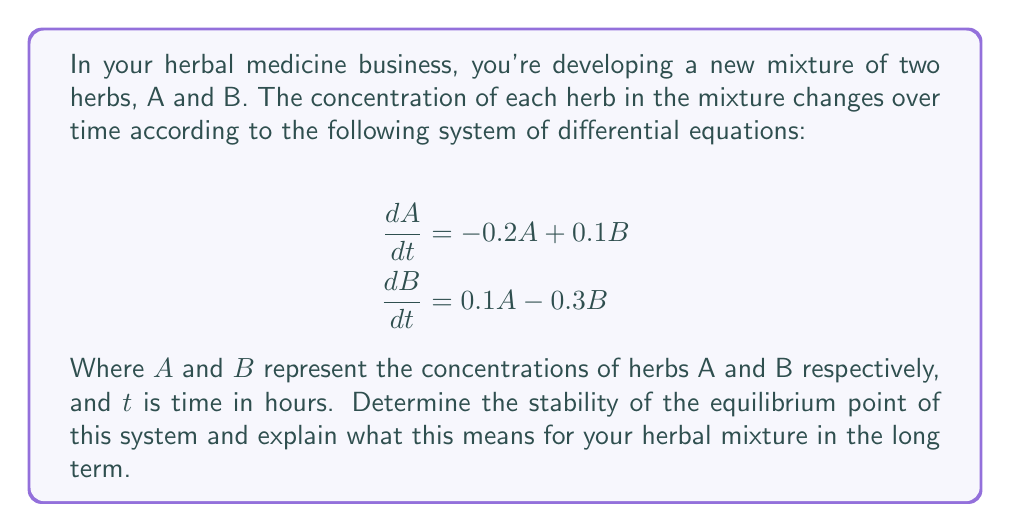Solve this math problem. 1) First, we need to find the equilibrium point by setting both equations to zero:

   $$-0.2A + 0.1B = 0$$
   $$0.1A - 0.3B = 0$$

2) Solving these equations simultaneously:
   From the second equation: $A = 3B$
   Substituting into the first equation:
   $$-0.2(3B) + 0.1B = 0$$
   $$-0.6B + 0.1B = 0$$
   $$-0.5B = 0$$
   $$B = 0$$

   Therefore, $A = 0$ as well.

3) The equilibrium point is (0,0).

4) To determine stability, we need to find the Jacobian matrix:

   $$J = \begin{bmatrix}
   \frac{\partial}{\partial A}(-0.2A + 0.1B) & \frac{\partial}{\partial B}(-0.2A + 0.1B) \\
   \frac{\partial}{\partial A}(0.1A - 0.3B) & \frac{\partial}{\partial B}(0.1A - 0.3B)
   \end{bmatrix}$$

   $$J = \begin{bmatrix}
   -0.2 & 0.1 \\
   0.1 & -0.3
   \end{bmatrix}$$

5) Calculate the eigenvalues of J:
   $$det(J - \lambda I) = 0$$
   $$\begin{vmatrix}
   -0.2 - \lambda & 0.1 \\
   0.1 & -0.3 - \lambda
   \end{vmatrix} = 0$$

   $$(-0.2 - \lambda)(-0.3 - \lambda) - 0.01 = 0$$
   $$\lambda^2 + 0.5\lambda + 0.05 = 0$$

6) Solving this quadratic equation:
   $$\lambda = \frac{-0.5 \pm \sqrt{0.25 - 0.2}}{2} = \frac{-0.5 \pm \sqrt{0.05}}{2}$$

   $$\lambda_1 \approx -0.3881$$
   $$\lambda_2 \approx -0.1119$$

7) Both eigenvalues are real and negative, which means the equilibrium point (0,0) is a stable node.

This means that regardless of the initial concentrations of herbs A and B, the mixture will eventually stabilize with both concentrations approaching zero over time.
Answer: Stable node at (0,0); both herb concentrations will approach zero over time. 